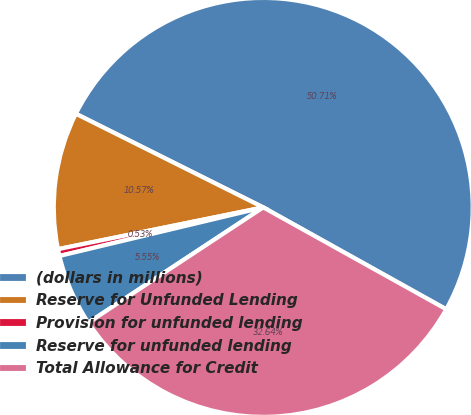<chart> <loc_0><loc_0><loc_500><loc_500><pie_chart><fcel>(dollars in millions)<fcel>Reserve for Unfunded Lending<fcel>Provision for unfunded lending<fcel>Reserve for unfunded lending<fcel>Total Allowance for Credit<nl><fcel>50.71%<fcel>10.57%<fcel>0.53%<fcel>5.55%<fcel>32.64%<nl></chart> 